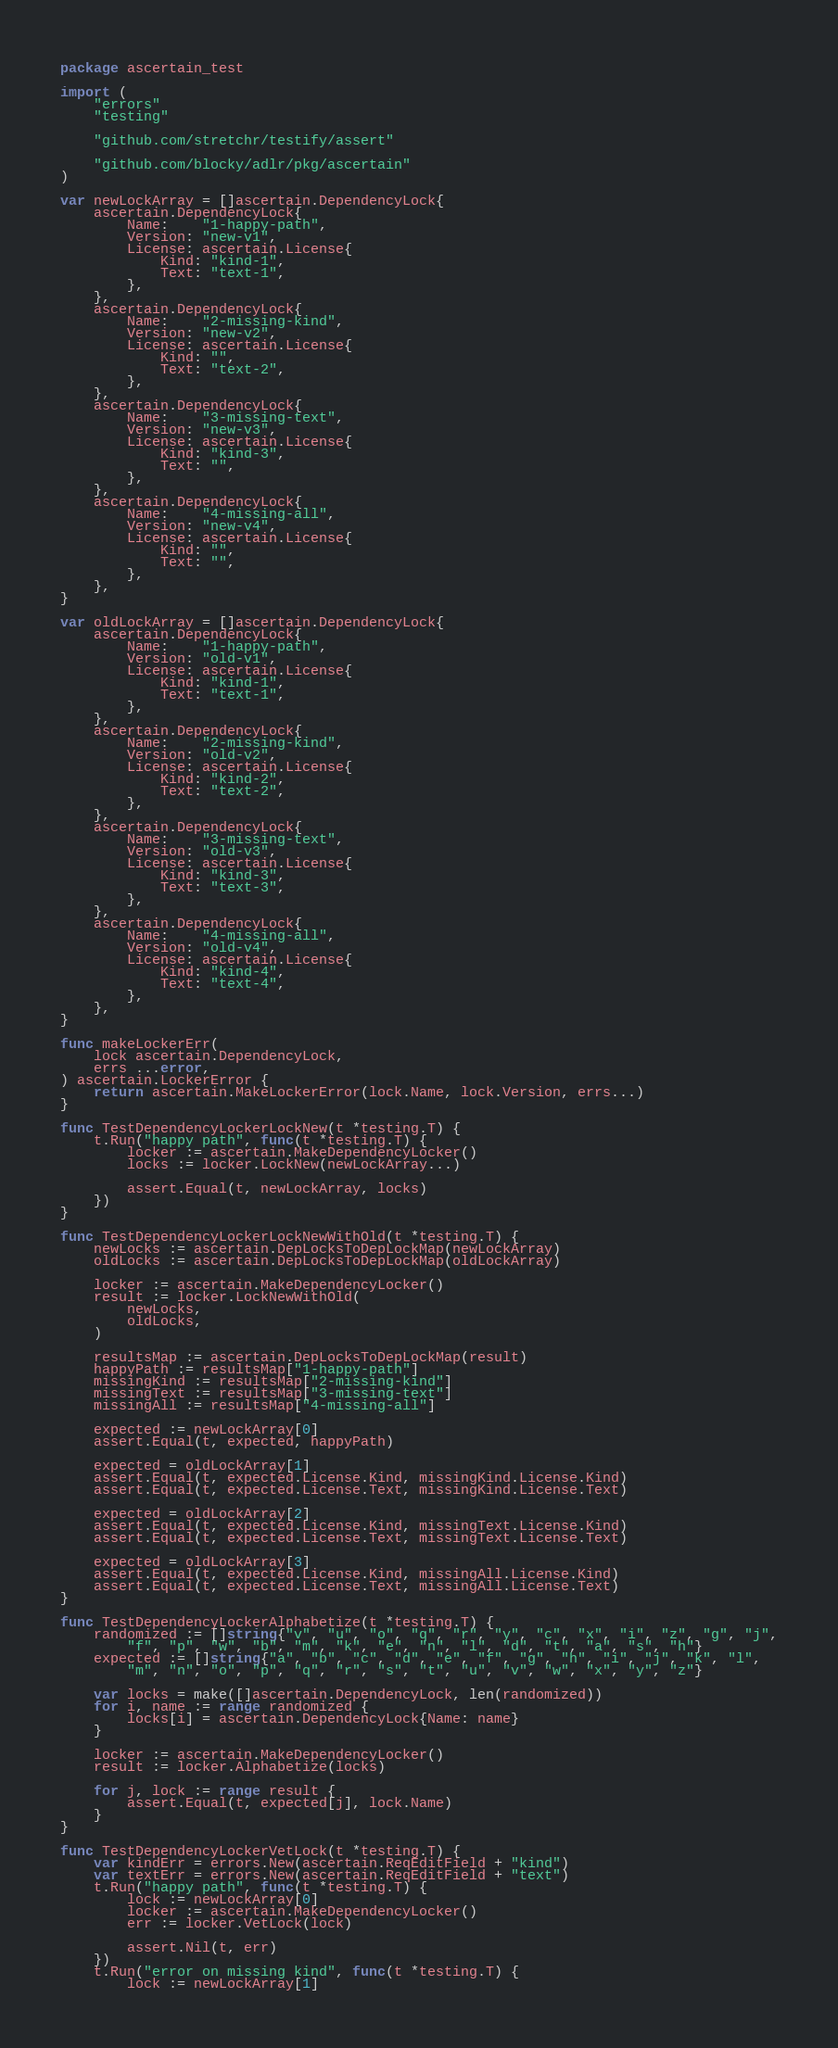<code> <loc_0><loc_0><loc_500><loc_500><_Go_>package ascertain_test

import (
	"errors"
	"testing"

	"github.com/stretchr/testify/assert"

	"github.com/blocky/adlr/pkg/ascertain"
)

var newLockArray = []ascertain.DependencyLock{
	ascertain.DependencyLock{
		Name:    "1-happy-path",
		Version: "new-v1",
		License: ascertain.License{
			Kind: "kind-1",
			Text: "text-1",
		},
	},
	ascertain.DependencyLock{
		Name:    "2-missing-kind",
		Version: "new-v2",
		License: ascertain.License{
			Kind: "",
			Text: "text-2",
		},
	},
	ascertain.DependencyLock{
		Name:    "3-missing-text",
		Version: "new-v3",
		License: ascertain.License{
			Kind: "kind-3",
			Text: "",
		},
	},
	ascertain.DependencyLock{
		Name:    "4-missing-all",
		Version: "new-v4",
		License: ascertain.License{
			Kind: "",
			Text: "",
		},
	},
}

var oldLockArray = []ascertain.DependencyLock{
	ascertain.DependencyLock{
		Name:    "1-happy-path",
		Version: "old-v1",
		License: ascertain.License{
			Kind: "kind-1",
			Text: "text-1",
		},
	},
	ascertain.DependencyLock{
		Name:    "2-missing-kind",
		Version: "old-v2",
		License: ascertain.License{
			Kind: "kind-2",
			Text: "text-2",
		},
	},
	ascertain.DependencyLock{
		Name:    "3-missing-text",
		Version: "old-v3",
		License: ascertain.License{
			Kind: "kind-3",
			Text: "text-3",
		},
	},
	ascertain.DependencyLock{
		Name:    "4-missing-all",
		Version: "old-v4",
		License: ascertain.License{
			Kind: "kind-4",
			Text: "text-4",
		},
	},
}

func makeLockerErr(
	lock ascertain.DependencyLock,
	errs ...error,
) ascertain.LockerError {
	return ascertain.MakeLockerError(lock.Name, lock.Version, errs...)
}

func TestDependencyLockerLockNew(t *testing.T) {
	t.Run("happy path", func(t *testing.T) {
		locker := ascertain.MakeDependencyLocker()
		locks := locker.LockNew(newLockArray...)

		assert.Equal(t, newLockArray, locks)
	})
}

func TestDependencyLockerLockNewWithOld(t *testing.T) {
	newLocks := ascertain.DepLocksToDepLockMap(newLockArray)
	oldLocks := ascertain.DepLocksToDepLockMap(oldLockArray)

	locker := ascertain.MakeDependencyLocker()
	result := locker.LockNewWithOld(
		newLocks,
		oldLocks,
	)

	resultsMap := ascertain.DepLocksToDepLockMap(result)
	happyPath := resultsMap["1-happy-path"]
	missingKind := resultsMap["2-missing-kind"]
	missingText := resultsMap["3-missing-text"]
	missingAll := resultsMap["4-missing-all"]

	expected := newLockArray[0]
	assert.Equal(t, expected, happyPath)

	expected = oldLockArray[1]
	assert.Equal(t, expected.License.Kind, missingKind.License.Kind)
	assert.Equal(t, expected.License.Text, missingKind.License.Text)

	expected = oldLockArray[2]
	assert.Equal(t, expected.License.Kind, missingText.License.Kind)
	assert.Equal(t, expected.License.Text, missingText.License.Text)

	expected = oldLockArray[3]
	assert.Equal(t, expected.License.Kind, missingAll.License.Kind)
	assert.Equal(t, expected.License.Text, missingAll.License.Text)
}

func TestDependencyLockerAlphabetize(t *testing.T) {
	randomized := []string{"v", "u", "o", "q", "r", "y", "c", "x", "i", "z", "g", "j",
		"f", "p", "w", "b", "m", "k", "e", "n", "l", "d", "t", "a", "s", "h"}
	expected := []string{"a", "b", "c", "d", "e", "f", "g", "h", "i", "j", "k", "l",
		"m", "n", "o", "p", "q", "r", "s", "t", "u", "v", "w", "x", "y", "z"}

	var locks = make([]ascertain.DependencyLock, len(randomized))
	for i, name := range randomized {
		locks[i] = ascertain.DependencyLock{Name: name}
	}

	locker := ascertain.MakeDependencyLocker()
	result := locker.Alphabetize(locks)

	for j, lock := range result {
		assert.Equal(t, expected[j], lock.Name)
	}
}

func TestDependencyLockerVetLock(t *testing.T) {
	var kindErr = errors.New(ascertain.ReqEditField + "kind")
	var textErr = errors.New(ascertain.ReqEditField + "text")
	t.Run("happy path", func(t *testing.T) {
		lock := newLockArray[0]
		locker := ascertain.MakeDependencyLocker()
		err := locker.VetLock(lock)

		assert.Nil(t, err)
	})
	t.Run("error on missing kind", func(t *testing.T) {
		lock := newLockArray[1]</code> 